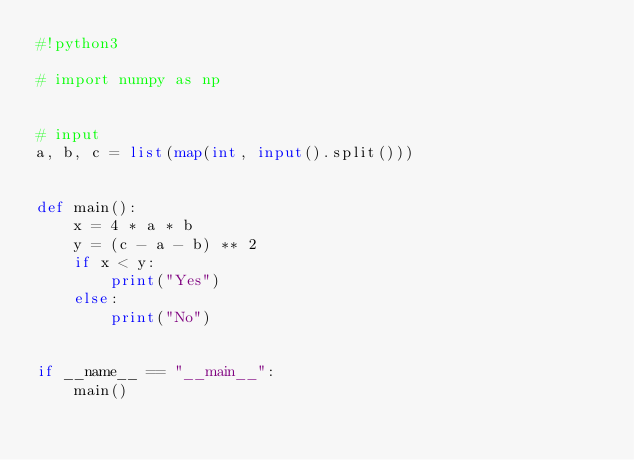Convert code to text. <code><loc_0><loc_0><loc_500><loc_500><_Python_>#!python3

# import numpy as np


# input
a, b, c = list(map(int, input().split()))


def main():
    x = 4 * a * b
    y = (c - a - b) ** 2
    if x < y:
        print("Yes")
    else:
        print("No")


if __name__ == "__main__":
    main()
</code> 